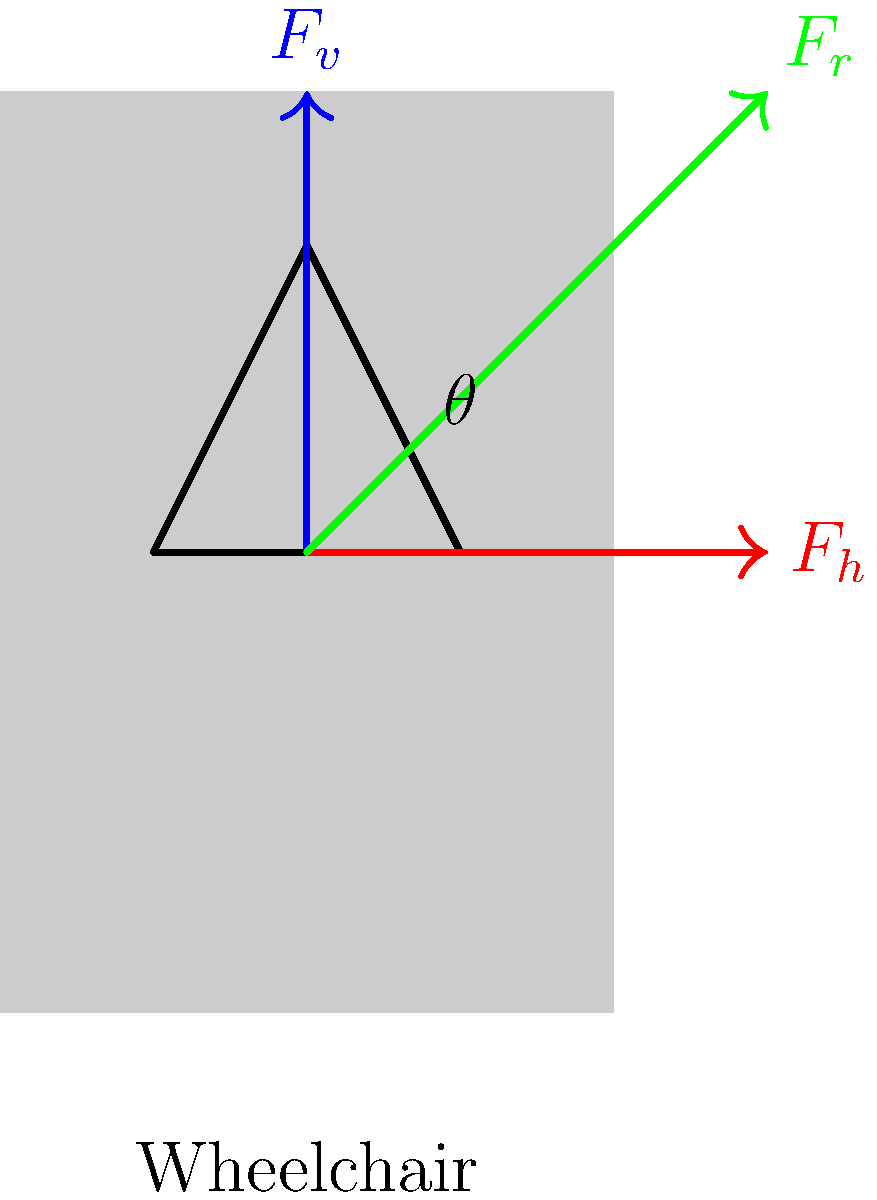In wheelchair propulsion, a social worker applies a force to the handrims. The diagram shows the forces involved: vertical force ($F_v$), horizontal force ($F_h$), and the resultant force ($F_r$). If the angle between the horizontal and the resultant force is $\theta$, and $F_v = 50$ N and $F_h = 75$ N, calculate the magnitude of the resultant force $F_r$. To solve this problem, we'll use the Pythagorean theorem, as the forces form a right-angled triangle:

1. Identify the known forces:
   $F_v = 50$ N (vertical force)
   $F_h = 75$ N (horizontal force)

2. Use the Pythagorean theorem to calculate $F_r$:
   $F_r^2 = F_v^2 + F_h^2$

3. Substitute the known values:
   $F_r^2 = 50^2 + 75^2$

4. Calculate the squares:
   $F_r^2 = 2500 + 5625 = 8125$

5. Take the square root of both sides:
   $F_r = \sqrt{8125}$

6. Simplify:
   $F_r \approx 90.14$ N

Therefore, the magnitude of the resultant force $F_r$ is approximately 90.14 N.

Note: The angle $\theta$ can be calculated using trigonometry if needed:
$\theta = \tan^{-1}(\frac{F_v}{F_h}) = \tan^{-1}(\frac{50}{75}) \approx 33.69°$
Answer: 90.14 N 